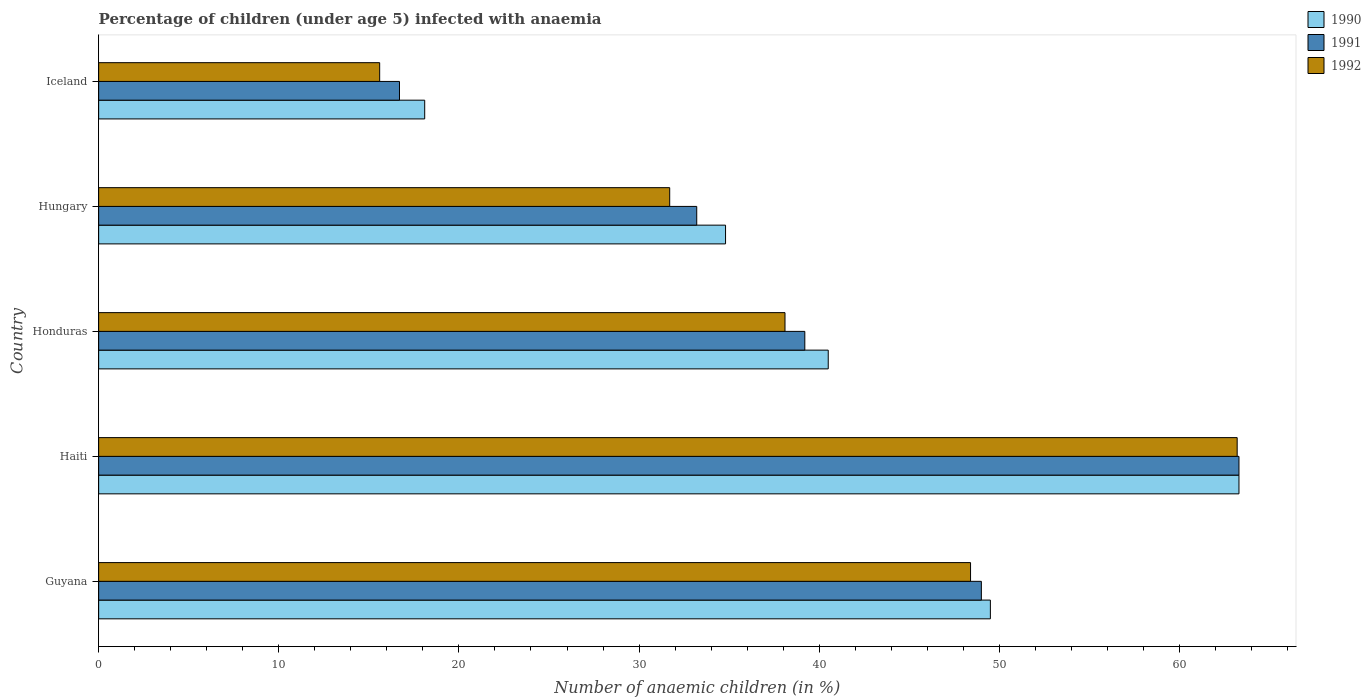How many different coloured bars are there?
Offer a very short reply. 3. Are the number of bars per tick equal to the number of legend labels?
Keep it short and to the point. Yes. How many bars are there on the 4th tick from the bottom?
Offer a very short reply. 3. What is the label of the 2nd group of bars from the top?
Give a very brief answer. Hungary. Across all countries, what is the maximum percentage of children infected with anaemia in in 1990?
Offer a very short reply. 63.3. In which country was the percentage of children infected with anaemia in in 1990 maximum?
Give a very brief answer. Haiti. What is the total percentage of children infected with anaemia in in 1990 in the graph?
Ensure brevity in your answer.  206.2. What is the difference between the percentage of children infected with anaemia in in 1992 in Haiti and that in Hungary?
Ensure brevity in your answer.  31.5. What is the difference between the percentage of children infected with anaemia in in 1990 in Iceland and the percentage of children infected with anaemia in in 1991 in Haiti?
Your answer should be very brief. -45.2. What is the average percentage of children infected with anaemia in in 1990 per country?
Ensure brevity in your answer.  41.24. What is the difference between the percentage of children infected with anaemia in in 1990 and percentage of children infected with anaemia in in 1992 in Guyana?
Provide a short and direct response. 1.1. In how many countries, is the percentage of children infected with anaemia in in 1992 greater than 2 %?
Give a very brief answer. 5. What is the ratio of the percentage of children infected with anaemia in in 1990 in Honduras to that in Hungary?
Ensure brevity in your answer.  1.16. What is the difference between the highest and the second highest percentage of children infected with anaemia in in 1990?
Your answer should be very brief. 13.8. What is the difference between the highest and the lowest percentage of children infected with anaemia in in 1990?
Make the answer very short. 45.2. In how many countries, is the percentage of children infected with anaemia in in 1991 greater than the average percentage of children infected with anaemia in in 1991 taken over all countries?
Make the answer very short. 2. Is the sum of the percentage of children infected with anaemia in in 1992 in Haiti and Iceland greater than the maximum percentage of children infected with anaemia in in 1990 across all countries?
Provide a short and direct response. Yes. What does the 3rd bar from the bottom in Honduras represents?
Your answer should be compact. 1992. Are all the bars in the graph horizontal?
Provide a succinct answer. Yes. How many countries are there in the graph?
Your response must be concise. 5. What is the difference between two consecutive major ticks on the X-axis?
Offer a terse response. 10. Where does the legend appear in the graph?
Your answer should be very brief. Top right. How many legend labels are there?
Provide a succinct answer. 3. How are the legend labels stacked?
Give a very brief answer. Vertical. What is the title of the graph?
Provide a short and direct response. Percentage of children (under age 5) infected with anaemia. Does "2009" appear as one of the legend labels in the graph?
Your answer should be very brief. No. What is the label or title of the X-axis?
Your response must be concise. Number of anaemic children (in %). What is the label or title of the Y-axis?
Your answer should be very brief. Country. What is the Number of anaemic children (in %) of 1990 in Guyana?
Your answer should be very brief. 49.5. What is the Number of anaemic children (in %) of 1991 in Guyana?
Your response must be concise. 49. What is the Number of anaemic children (in %) of 1992 in Guyana?
Offer a very short reply. 48.4. What is the Number of anaemic children (in %) in 1990 in Haiti?
Offer a terse response. 63.3. What is the Number of anaemic children (in %) in 1991 in Haiti?
Your response must be concise. 63.3. What is the Number of anaemic children (in %) in 1992 in Haiti?
Your answer should be compact. 63.2. What is the Number of anaemic children (in %) in 1990 in Honduras?
Your answer should be compact. 40.5. What is the Number of anaemic children (in %) in 1991 in Honduras?
Offer a terse response. 39.2. What is the Number of anaemic children (in %) of 1992 in Honduras?
Provide a succinct answer. 38.1. What is the Number of anaemic children (in %) in 1990 in Hungary?
Ensure brevity in your answer.  34.8. What is the Number of anaemic children (in %) in 1991 in Hungary?
Keep it short and to the point. 33.2. What is the Number of anaemic children (in %) of 1992 in Hungary?
Your response must be concise. 31.7. What is the Number of anaemic children (in %) in 1992 in Iceland?
Ensure brevity in your answer.  15.6. Across all countries, what is the maximum Number of anaemic children (in %) of 1990?
Your answer should be very brief. 63.3. Across all countries, what is the maximum Number of anaemic children (in %) in 1991?
Provide a succinct answer. 63.3. Across all countries, what is the maximum Number of anaemic children (in %) of 1992?
Give a very brief answer. 63.2. Across all countries, what is the minimum Number of anaemic children (in %) of 1990?
Keep it short and to the point. 18.1. What is the total Number of anaemic children (in %) of 1990 in the graph?
Offer a very short reply. 206.2. What is the total Number of anaemic children (in %) of 1991 in the graph?
Your response must be concise. 201.4. What is the total Number of anaemic children (in %) in 1992 in the graph?
Your answer should be very brief. 197. What is the difference between the Number of anaemic children (in %) of 1990 in Guyana and that in Haiti?
Your answer should be very brief. -13.8. What is the difference between the Number of anaemic children (in %) of 1991 in Guyana and that in Haiti?
Keep it short and to the point. -14.3. What is the difference between the Number of anaemic children (in %) in 1992 in Guyana and that in Haiti?
Offer a very short reply. -14.8. What is the difference between the Number of anaemic children (in %) of 1991 in Guyana and that in Honduras?
Give a very brief answer. 9.8. What is the difference between the Number of anaemic children (in %) in 1992 in Guyana and that in Honduras?
Provide a short and direct response. 10.3. What is the difference between the Number of anaemic children (in %) in 1990 in Guyana and that in Hungary?
Your answer should be very brief. 14.7. What is the difference between the Number of anaemic children (in %) of 1991 in Guyana and that in Hungary?
Keep it short and to the point. 15.8. What is the difference between the Number of anaemic children (in %) in 1990 in Guyana and that in Iceland?
Provide a short and direct response. 31.4. What is the difference between the Number of anaemic children (in %) in 1991 in Guyana and that in Iceland?
Your response must be concise. 32.3. What is the difference between the Number of anaemic children (in %) of 1992 in Guyana and that in Iceland?
Offer a terse response. 32.8. What is the difference between the Number of anaemic children (in %) in 1990 in Haiti and that in Honduras?
Offer a terse response. 22.8. What is the difference between the Number of anaemic children (in %) of 1991 in Haiti and that in Honduras?
Offer a very short reply. 24.1. What is the difference between the Number of anaemic children (in %) of 1992 in Haiti and that in Honduras?
Provide a succinct answer. 25.1. What is the difference between the Number of anaemic children (in %) of 1991 in Haiti and that in Hungary?
Ensure brevity in your answer.  30.1. What is the difference between the Number of anaemic children (in %) in 1992 in Haiti and that in Hungary?
Your response must be concise. 31.5. What is the difference between the Number of anaemic children (in %) of 1990 in Haiti and that in Iceland?
Your response must be concise. 45.2. What is the difference between the Number of anaemic children (in %) of 1991 in Haiti and that in Iceland?
Give a very brief answer. 46.6. What is the difference between the Number of anaemic children (in %) in 1992 in Haiti and that in Iceland?
Provide a short and direct response. 47.6. What is the difference between the Number of anaemic children (in %) of 1991 in Honduras and that in Hungary?
Give a very brief answer. 6. What is the difference between the Number of anaemic children (in %) of 1990 in Honduras and that in Iceland?
Your answer should be very brief. 22.4. What is the difference between the Number of anaemic children (in %) of 1991 in Hungary and that in Iceland?
Ensure brevity in your answer.  16.5. What is the difference between the Number of anaemic children (in %) of 1990 in Guyana and the Number of anaemic children (in %) of 1991 in Haiti?
Provide a succinct answer. -13.8. What is the difference between the Number of anaemic children (in %) in 1990 in Guyana and the Number of anaemic children (in %) in 1992 in Haiti?
Provide a short and direct response. -13.7. What is the difference between the Number of anaemic children (in %) in 1991 in Guyana and the Number of anaemic children (in %) in 1992 in Haiti?
Your answer should be very brief. -14.2. What is the difference between the Number of anaemic children (in %) in 1990 in Guyana and the Number of anaemic children (in %) in 1992 in Honduras?
Give a very brief answer. 11.4. What is the difference between the Number of anaemic children (in %) of 1991 in Guyana and the Number of anaemic children (in %) of 1992 in Honduras?
Offer a very short reply. 10.9. What is the difference between the Number of anaemic children (in %) of 1991 in Guyana and the Number of anaemic children (in %) of 1992 in Hungary?
Give a very brief answer. 17.3. What is the difference between the Number of anaemic children (in %) in 1990 in Guyana and the Number of anaemic children (in %) in 1991 in Iceland?
Offer a very short reply. 32.8. What is the difference between the Number of anaemic children (in %) in 1990 in Guyana and the Number of anaemic children (in %) in 1992 in Iceland?
Offer a terse response. 33.9. What is the difference between the Number of anaemic children (in %) of 1991 in Guyana and the Number of anaemic children (in %) of 1992 in Iceland?
Make the answer very short. 33.4. What is the difference between the Number of anaemic children (in %) of 1990 in Haiti and the Number of anaemic children (in %) of 1991 in Honduras?
Make the answer very short. 24.1. What is the difference between the Number of anaemic children (in %) of 1990 in Haiti and the Number of anaemic children (in %) of 1992 in Honduras?
Keep it short and to the point. 25.2. What is the difference between the Number of anaemic children (in %) of 1991 in Haiti and the Number of anaemic children (in %) of 1992 in Honduras?
Your response must be concise. 25.2. What is the difference between the Number of anaemic children (in %) of 1990 in Haiti and the Number of anaemic children (in %) of 1991 in Hungary?
Your answer should be compact. 30.1. What is the difference between the Number of anaemic children (in %) of 1990 in Haiti and the Number of anaemic children (in %) of 1992 in Hungary?
Provide a succinct answer. 31.6. What is the difference between the Number of anaemic children (in %) of 1991 in Haiti and the Number of anaemic children (in %) of 1992 in Hungary?
Your answer should be compact. 31.6. What is the difference between the Number of anaemic children (in %) in 1990 in Haiti and the Number of anaemic children (in %) in 1991 in Iceland?
Your answer should be compact. 46.6. What is the difference between the Number of anaemic children (in %) of 1990 in Haiti and the Number of anaemic children (in %) of 1992 in Iceland?
Offer a very short reply. 47.7. What is the difference between the Number of anaemic children (in %) of 1991 in Haiti and the Number of anaemic children (in %) of 1992 in Iceland?
Provide a succinct answer. 47.7. What is the difference between the Number of anaemic children (in %) of 1990 in Honduras and the Number of anaemic children (in %) of 1991 in Hungary?
Provide a succinct answer. 7.3. What is the difference between the Number of anaemic children (in %) in 1991 in Honduras and the Number of anaemic children (in %) in 1992 in Hungary?
Provide a short and direct response. 7.5. What is the difference between the Number of anaemic children (in %) of 1990 in Honduras and the Number of anaemic children (in %) of 1991 in Iceland?
Offer a terse response. 23.8. What is the difference between the Number of anaemic children (in %) in 1990 in Honduras and the Number of anaemic children (in %) in 1992 in Iceland?
Give a very brief answer. 24.9. What is the difference between the Number of anaemic children (in %) in 1991 in Honduras and the Number of anaemic children (in %) in 1992 in Iceland?
Make the answer very short. 23.6. What is the difference between the Number of anaemic children (in %) in 1990 in Hungary and the Number of anaemic children (in %) in 1991 in Iceland?
Offer a terse response. 18.1. What is the difference between the Number of anaemic children (in %) of 1990 in Hungary and the Number of anaemic children (in %) of 1992 in Iceland?
Provide a short and direct response. 19.2. What is the difference between the Number of anaemic children (in %) of 1991 in Hungary and the Number of anaemic children (in %) of 1992 in Iceland?
Offer a very short reply. 17.6. What is the average Number of anaemic children (in %) in 1990 per country?
Your response must be concise. 41.24. What is the average Number of anaemic children (in %) in 1991 per country?
Provide a short and direct response. 40.28. What is the average Number of anaemic children (in %) in 1992 per country?
Ensure brevity in your answer.  39.4. What is the difference between the Number of anaemic children (in %) of 1990 and Number of anaemic children (in %) of 1991 in Guyana?
Keep it short and to the point. 0.5. What is the difference between the Number of anaemic children (in %) in 1990 and Number of anaemic children (in %) in 1992 in Guyana?
Make the answer very short. 1.1. What is the difference between the Number of anaemic children (in %) of 1990 and Number of anaemic children (in %) of 1991 in Haiti?
Your response must be concise. 0. What is the difference between the Number of anaemic children (in %) of 1990 and Number of anaemic children (in %) of 1992 in Haiti?
Your response must be concise. 0.1. What is the difference between the Number of anaemic children (in %) in 1990 and Number of anaemic children (in %) in 1991 in Honduras?
Provide a short and direct response. 1.3. What is the difference between the Number of anaemic children (in %) of 1991 and Number of anaemic children (in %) of 1992 in Honduras?
Provide a succinct answer. 1.1. What is the difference between the Number of anaemic children (in %) of 1991 and Number of anaemic children (in %) of 1992 in Hungary?
Keep it short and to the point. 1.5. What is the difference between the Number of anaemic children (in %) in 1990 and Number of anaemic children (in %) in 1991 in Iceland?
Offer a very short reply. 1.4. What is the ratio of the Number of anaemic children (in %) of 1990 in Guyana to that in Haiti?
Offer a terse response. 0.78. What is the ratio of the Number of anaemic children (in %) in 1991 in Guyana to that in Haiti?
Make the answer very short. 0.77. What is the ratio of the Number of anaemic children (in %) in 1992 in Guyana to that in Haiti?
Your answer should be compact. 0.77. What is the ratio of the Number of anaemic children (in %) in 1990 in Guyana to that in Honduras?
Give a very brief answer. 1.22. What is the ratio of the Number of anaemic children (in %) of 1992 in Guyana to that in Honduras?
Your response must be concise. 1.27. What is the ratio of the Number of anaemic children (in %) of 1990 in Guyana to that in Hungary?
Offer a very short reply. 1.42. What is the ratio of the Number of anaemic children (in %) of 1991 in Guyana to that in Hungary?
Offer a terse response. 1.48. What is the ratio of the Number of anaemic children (in %) of 1992 in Guyana to that in Hungary?
Give a very brief answer. 1.53. What is the ratio of the Number of anaemic children (in %) in 1990 in Guyana to that in Iceland?
Your answer should be compact. 2.73. What is the ratio of the Number of anaemic children (in %) of 1991 in Guyana to that in Iceland?
Make the answer very short. 2.93. What is the ratio of the Number of anaemic children (in %) of 1992 in Guyana to that in Iceland?
Offer a terse response. 3.1. What is the ratio of the Number of anaemic children (in %) of 1990 in Haiti to that in Honduras?
Ensure brevity in your answer.  1.56. What is the ratio of the Number of anaemic children (in %) of 1991 in Haiti to that in Honduras?
Provide a succinct answer. 1.61. What is the ratio of the Number of anaemic children (in %) of 1992 in Haiti to that in Honduras?
Keep it short and to the point. 1.66. What is the ratio of the Number of anaemic children (in %) in 1990 in Haiti to that in Hungary?
Your response must be concise. 1.82. What is the ratio of the Number of anaemic children (in %) of 1991 in Haiti to that in Hungary?
Offer a terse response. 1.91. What is the ratio of the Number of anaemic children (in %) in 1992 in Haiti to that in Hungary?
Your answer should be compact. 1.99. What is the ratio of the Number of anaemic children (in %) of 1990 in Haiti to that in Iceland?
Your response must be concise. 3.5. What is the ratio of the Number of anaemic children (in %) of 1991 in Haiti to that in Iceland?
Provide a succinct answer. 3.79. What is the ratio of the Number of anaemic children (in %) in 1992 in Haiti to that in Iceland?
Ensure brevity in your answer.  4.05. What is the ratio of the Number of anaemic children (in %) in 1990 in Honduras to that in Hungary?
Your answer should be very brief. 1.16. What is the ratio of the Number of anaemic children (in %) in 1991 in Honduras to that in Hungary?
Make the answer very short. 1.18. What is the ratio of the Number of anaemic children (in %) of 1992 in Honduras to that in Hungary?
Make the answer very short. 1.2. What is the ratio of the Number of anaemic children (in %) in 1990 in Honduras to that in Iceland?
Provide a succinct answer. 2.24. What is the ratio of the Number of anaemic children (in %) of 1991 in Honduras to that in Iceland?
Make the answer very short. 2.35. What is the ratio of the Number of anaemic children (in %) of 1992 in Honduras to that in Iceland?
Make the answer very short. 2.44. What is the ratio of the Number of anaemic children (in %) of 1990 in Hungary to that in Iceland?
Offer a very short reply. 1.92. What is the ratio of the Number of anaemic children (in %) in 1991 in Hungary to that in Iceland?
Ensure brevity in your answer.  1.99. What is the ratio of the Number of anaemic children (in %) of 1992 in Hungary to that in Iceland?
Offer a terse response. 2.03. What is the difference between the highest and the second highest Number of anaemic children (in %) in 1990?
Provide a succinct answer. 13.8. What is the difference between the highest and the second highest Number of anaemic children (in %) of 1992?
Ensure brevity in your answer.  14.8. What is the difference between the highest and the lowest Number of anaemic children (in %) in 1990?
Your response must be concise. 45.2. What is the difference between the highest and the lowest Number of anaemic children (in %) in 1991?
Provide a succinct answer. 46.6. What is the difference between the highest and the lowest Number of anaemic children (in %) in 1992?
Provide a succinct answer. 47.6. 